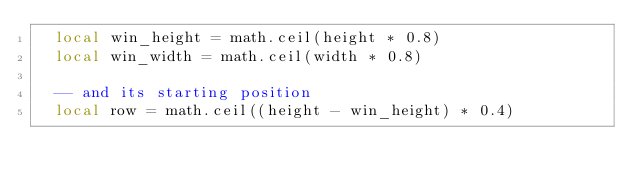<code> <loc_0><loc_0><loc_500><loc_500><_Lua_>  local win_height = math.ceil(height * 0.8)
  local win_width = math.ceil(width * 0.8)

  -- and its starting position
  local row = math.ceil((height - win_height) * 0.4)</code> 